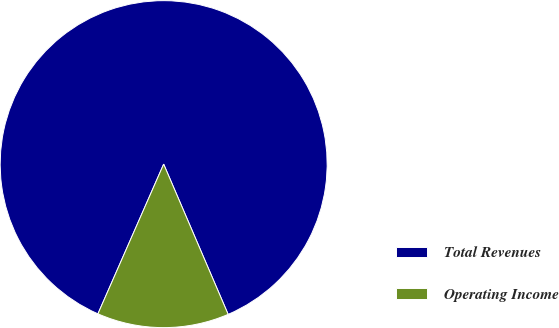Convert chart. <chart><loc_0><loc_0><loc_500><loc_500><pie_chart><fcel>Total Revenues<fcel>Operating Income<nl><fcel>86.96%<fcel>13.04%<nl></chart> 